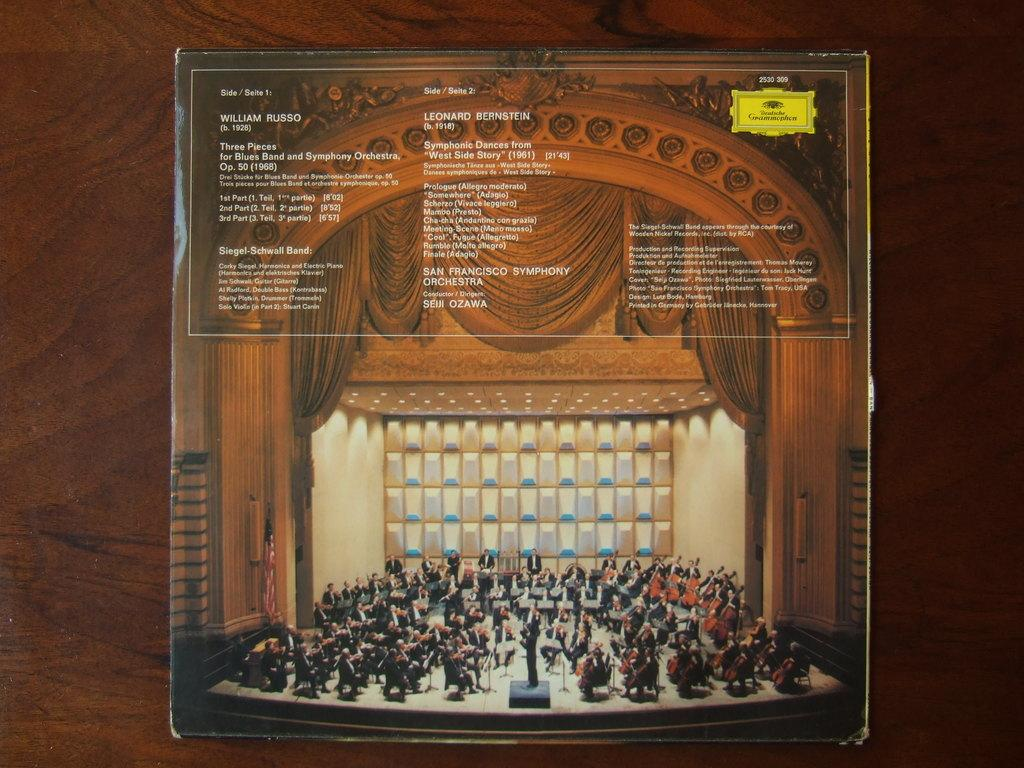What is the main object in the image? There is a board in the image. What is the color of the board's background? The board has a brown background. What can be seen on the board besides the background color? The board contains images of persons and text. How many houses are depicted on the board in the image? There is no house depicted on the board in the image; it contains images of persons and text. 